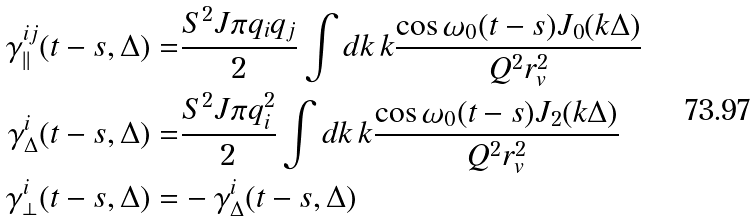<formula> <loc_0><loc_0><loc_500><loc_500>\gamma _ { | | } ^ { i j } ( t - s , \Delta ) = & \frac { S ^ { 2 } J \pi q _ { i } q _ { j } } { 2 } \int d k \, k \frac { \cos \omega _ { 0 } ( t - s ) J _ { 0 } ( k \Delta ) } { Q ^ { 2 } r _ { v } ^ { 2 } } \\ \gamma _ { \Delta } ^ { i } ( t - s , \Delta ) = & \frac { S ^ { 2 } J \pi q _ { i } ^ { 2 } } { 2 } \int d k \, k \frac { \cos \omega _ { 0 } ( t - s ) J _ { 2 } ( k \Delta ) } { Q ^ { 2 } r _ { v } ^ { 2 } } \\ \gamma _ { \bot } ^ { i } ( t - s , \Delta ) = & - \gamma _ { \Delta } ^ { i } ( t - s , \Delta )</formula> 